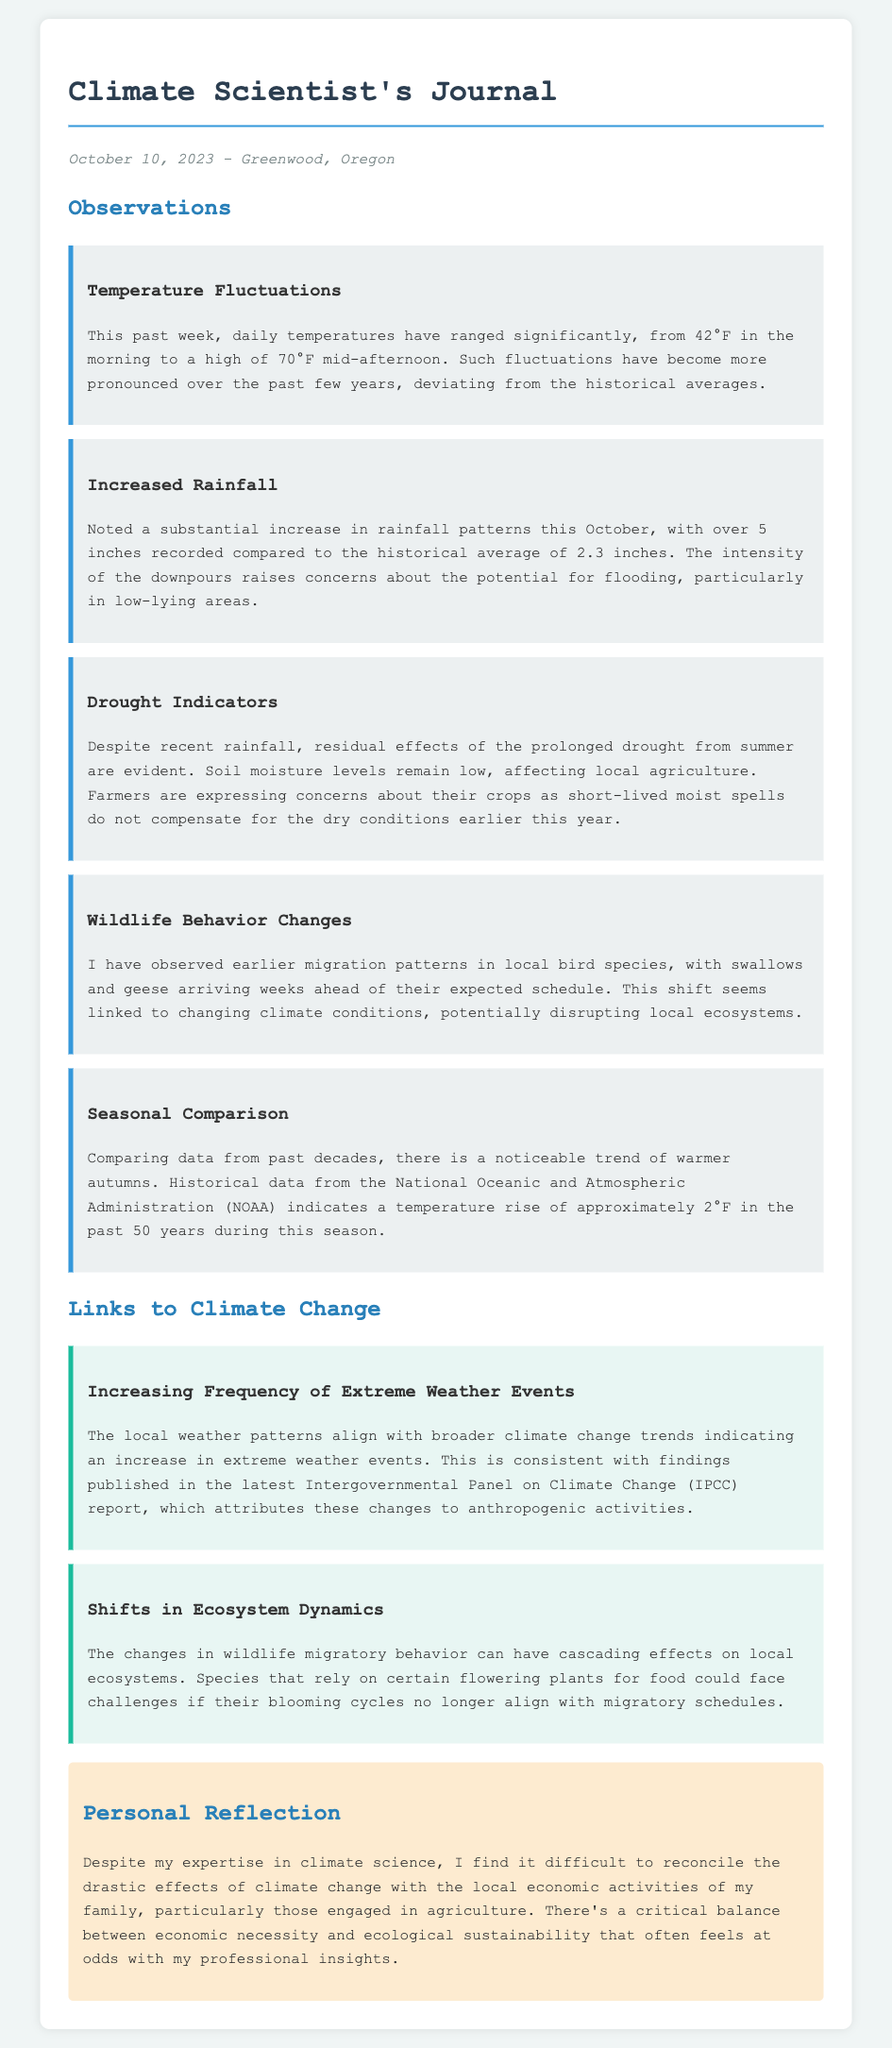What is the date of the journal entry? The journal entry is dated October 10, 2023.
Answer: October 10, 2023 What is the highest recorded temperature this past week? The highest recorded temperature is 70°F.
Answer: 70°F How much rainfall was recorded this October? The rainfall recorded this October is over 5 inches.
Answer: over 5 inches What animal migration pattern was observed? Earlier migration patterns in local bird species were noted.
Answer: Earlier migration patterns What is the temperature rise reported in the past 50 years for autumn? The temperature rise reported is approximately 2°F.
Answer: approximately 2°F What do recent changes in wildlife behavior potentially disrupt? They potentially disrupt local ecosystems.
Answer: local ecosystems What is the relationship between local weather patterns and climate change trends? The local weather patterns align with broader climate change trends.
Answer: align with broader climate change trends What critical balance is mentioned in the personal reflection? The balance between economic necessity and ecological sustainability.
Answer: economic necessity and ecological sustainability 